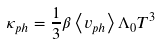Convert formula to latex. <formula><loc_0><loc_0><loc_500><loc_500>\kappa _ { p h } = \frac { 1 } { 3 } \beta \left \langle { v _ { p h } } \right \rangle \Lambda _ { 0 } T ^ { 3 }</formula> 